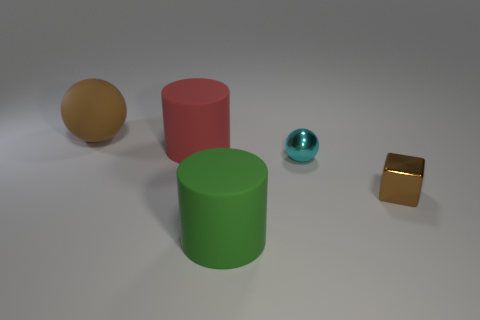Add 2 tiny gray spheres. How many objects exist? 7 Add 1 big brown balls. How many big brown balls exist? 2 Subtract all brown balls. How many balls are left? 1 Subtract 0 blue blocks. How many objects are left? 5 Subtract all spheres. How many objects are left? 3 Subtract 1 cylinders. How many cylinders are left? 1 Subtract all purple cylinders. Subtract all purple balls. How many cylinders are left? 2 Subtract all purple balls. How many red cubes are left? 0 Subtract all large green matte cylinders. Subtract all big cylinders. How many objects are left? 2 Add 5 brown matte things. How many brown matte things are left? 6 